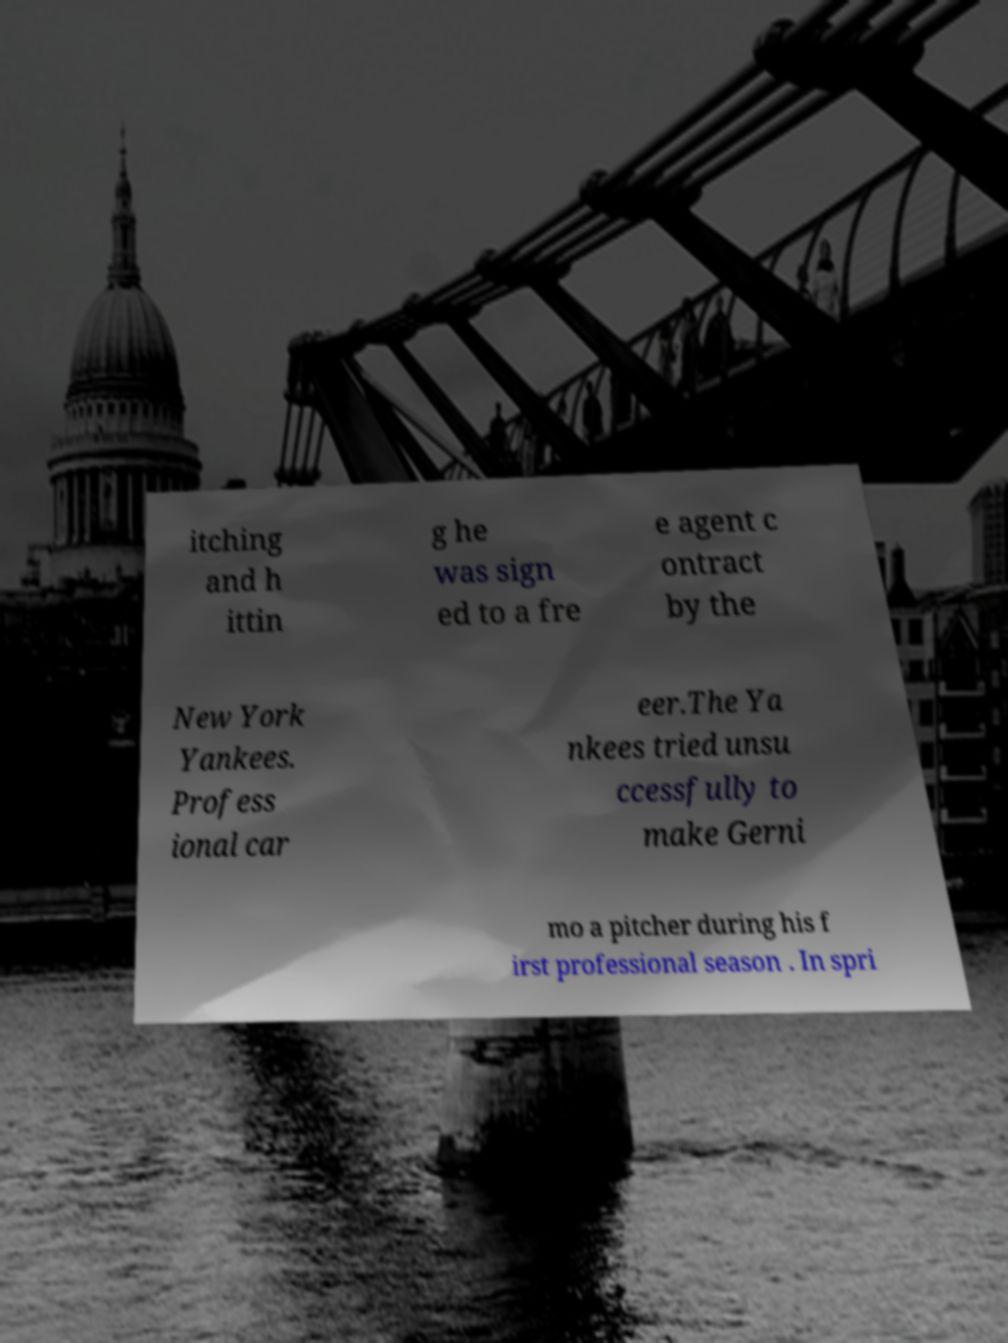I need the written content from this picture converted into text. Can you do that? itching and h ittin g he was sign ed to a fre e agent c ontract by the New York Yankees. Profess ional car eer.The Ya nkees tried unsu ccessfully to make Gerni mo a pitcher during his f irst professional season . In spri 